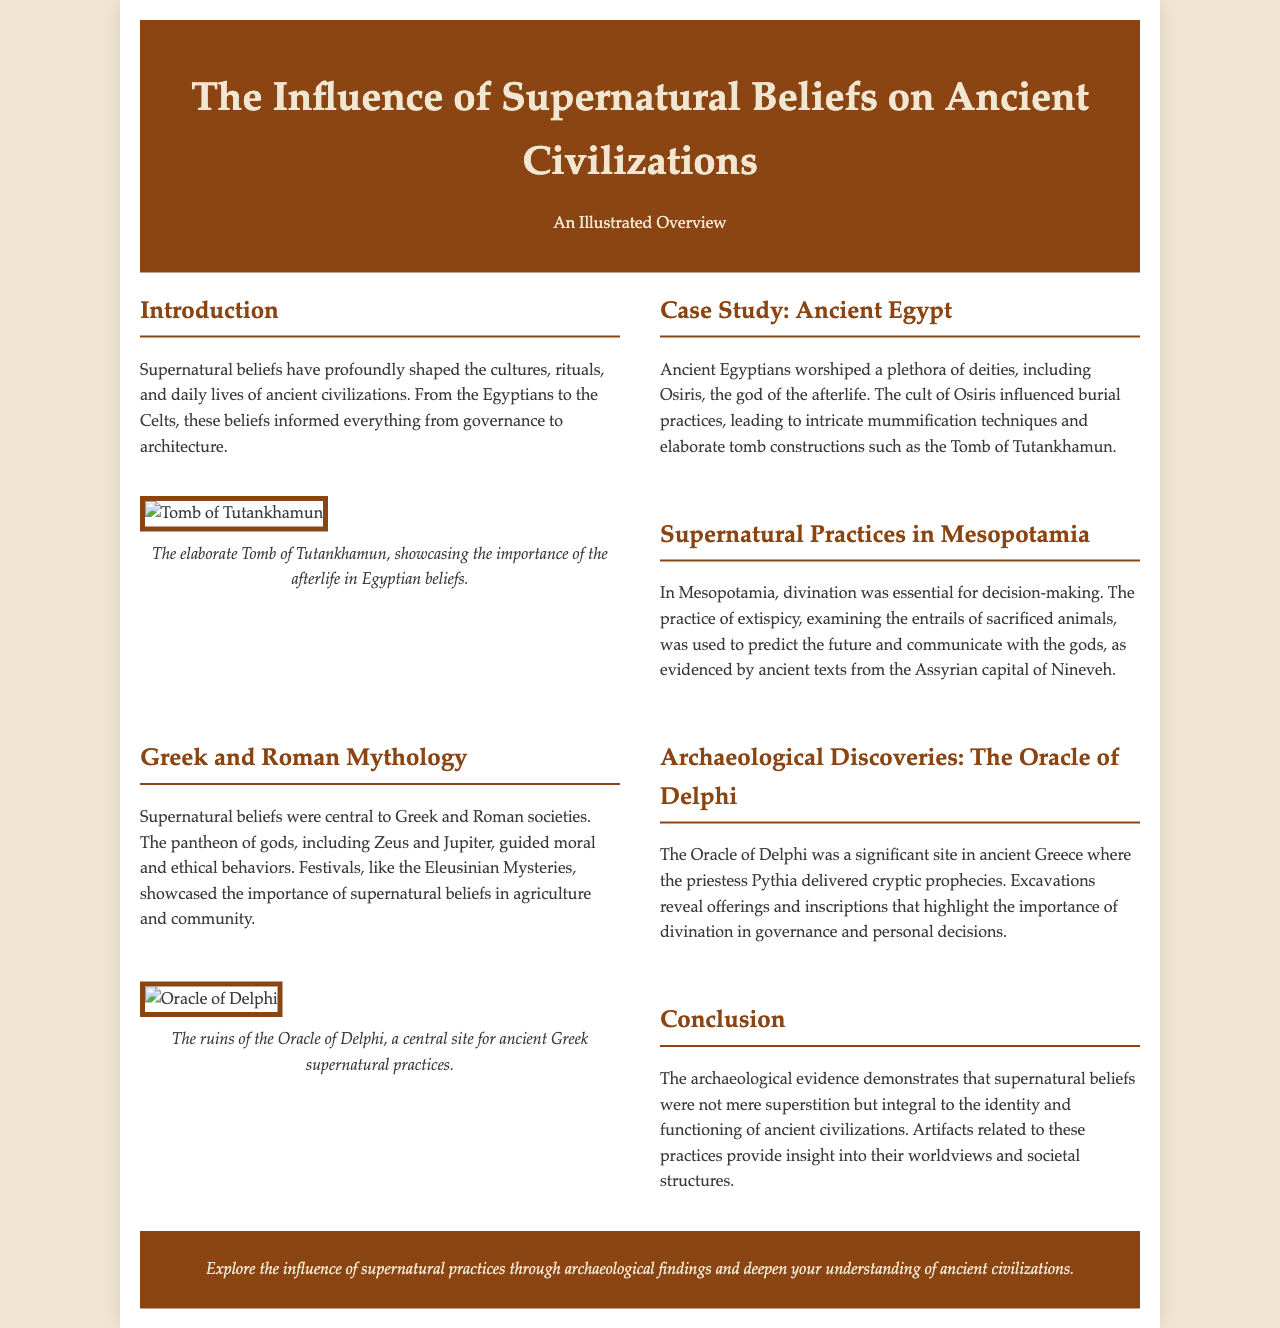What is the title of the document? The title of the document is mentioned in the header section, emphasizing its topic on supernatural beliefs in ancient civilizations.
Answer: The Influence of Supernatural Beliefs on Ancient Civilizations Which civilization is the focus of the case study? The document specifically highlights Ancient Egypt in the case study section, discussing its deities and practices.
Answer: Ancient Egypt What significant burial site is mentioned? The document refers to the Tomb of Tutankhamun as a notable burial site influenced by beliefs in the afterlife.
Answer: Tomb of Tutankhamun What was the practice used in Mesopotamia for divination? The text explains that extispicy, or examining entrails of sacrificed animals, was the divination practice in Mesopotamia.
Answer: Extispicy What site was significant for delivering prophecies in ancient Greece? The document names the Oracle of Delphi as a crucial site for prophecy delivery and supernatural practices.
Answer: Oracle of Delphi How were supernatural beliefs linked to agriculture in ancient societies? The festivals such as the Eleusinian Mysteries highlighted the relationship between supernatural beliefs and agricultural practices.
Answer: Festivals What was the primary role of supernatural beliefs in governance? The document states that supernatural beliefs influenced decision-making and governance across ancient civilizations, particularly through divination.
Answer: Decision-making Which deity is specifically mentioned in connection to burial practices? The text highlights Osiris, the god of the afterlife, as having a significant influence on burial practices in Ancient Egypt.
Answer: Osiris What kind of evidence is used to demonstrate the importance of supernatural beliefs? The document emphasizes archaeological findings and artifacts as key evidence illustrating the significance of supernatural beliefs.
Answer: Archaeological findings 